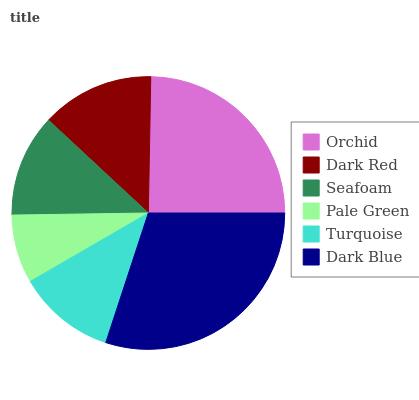Is Pale Green the minimum?
Answer yes or no. Yes. Is Dark Blue the maximum?
Answer yes or no. Yes. Is Dark Red the minimum?
Answer yes or no. No. Is Dark Red the maximum?
Answer yes or no. No. Is Orchid greater than Dark Red?
Answer yes or no. Yes. Is Dark Red less than Orchid?
Answer yes or no. Yes. Is Dark Red greater than Orchid?
Answer yes or no. No. Is Orchid less than Dark Red?
Answer yes or no. No. Is Dark Red the high median?
Answer yes or no. Yes. Is Seafoam the low median?
Answer yes or no. Yes. Is Seafoam the high median?
Answer yes or no. No. Is Turquoise the low median?
Answer yes or no. No. 